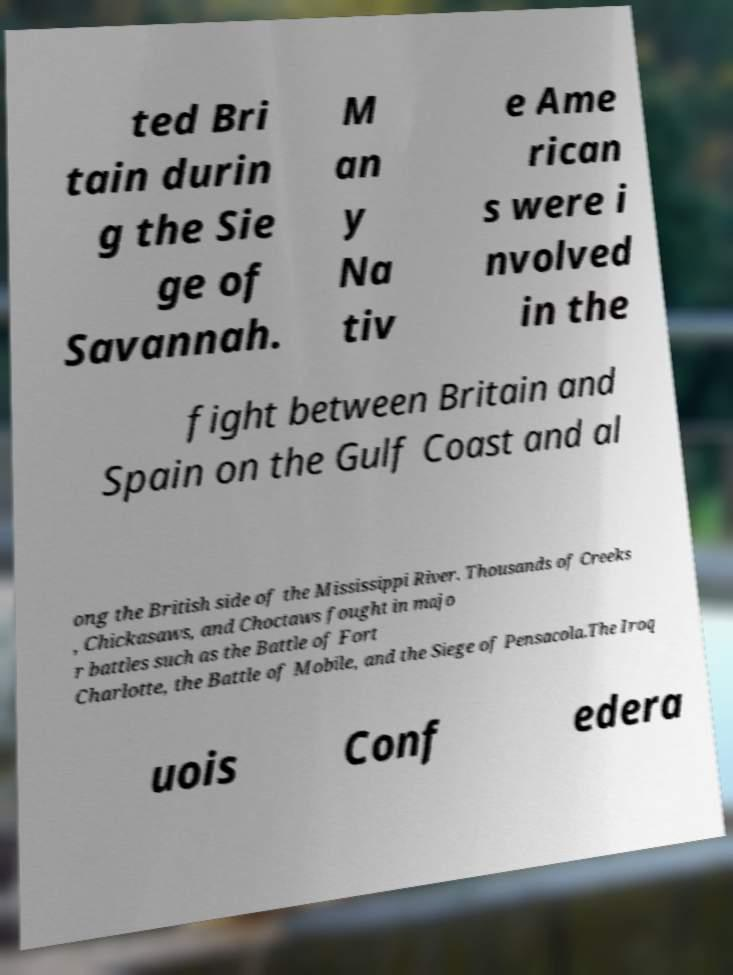Can you read and provide the text displayed in the image?This photo seems to have some interesting text. Can you extract and type it out for me? ted Bri tain durin g the Sie ge of Savannah. M an y Na tiv e Ame rican s were i nvolved in the fight between Britain and Spain on the Gulf Coast and al ong the British side of the Mississippi River. Thousands of Creeks , Chickasaws, and Choctaws fought in majo r battles such as the Battle of Fort Charlotte, the Battle of Mobile, and the Siege of Pensacola.The Iroq uois Conf edera 